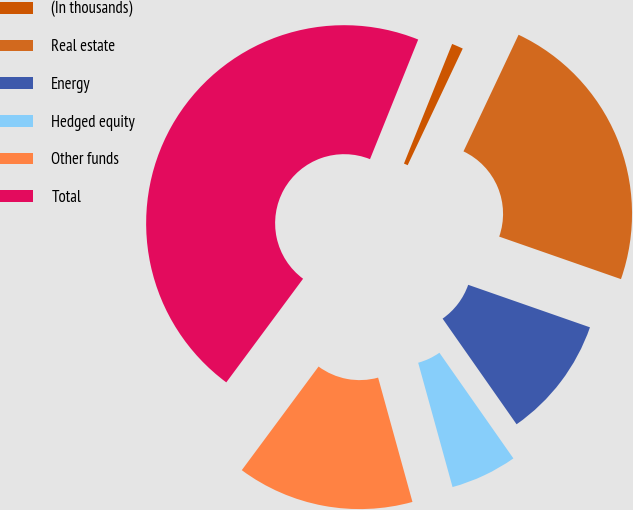<chart> <loc_0><loc_0><loc_500><loc_500><pie_chart><fcel>(In thousands)<fcel>Real estate<fcel>Energy<fcel>Hedged equity<fcel>Other funds<fcel>Total<nl><fcel>0.93%<fcel>23.32%<fcel>9.93%<fcel>5.43%<fcel>14.44%<fcel>45.94%<nl></chart> 